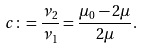Convert formula to latex. <formula><loc_0><loc_0><loc_500><loc_500>c \colon = \frac { \nu _ { 2 } } { \nu _ { 1 } } = \frac { \mu _ { 0 } - 2 \mu } { 2 \mu } .</formula> 